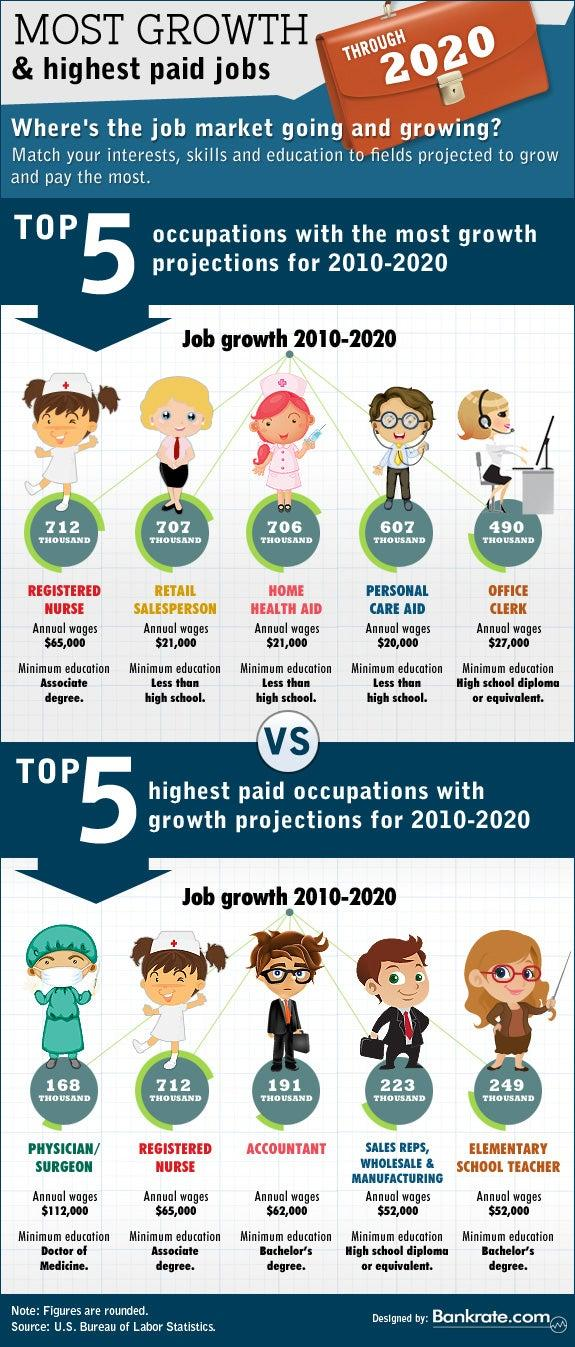Indicate a few pertinent items in this graphic. The highest paid job requires at least a high school diploma or equivalent for the position of SALES REPS in the WHOLESALE & MANUFACTURING industry. During the period of 2010 to 2020, registered nurses experienced the most growth in terms of job opportunities. The lowest annual wages are received by those in the personal care aid field, 